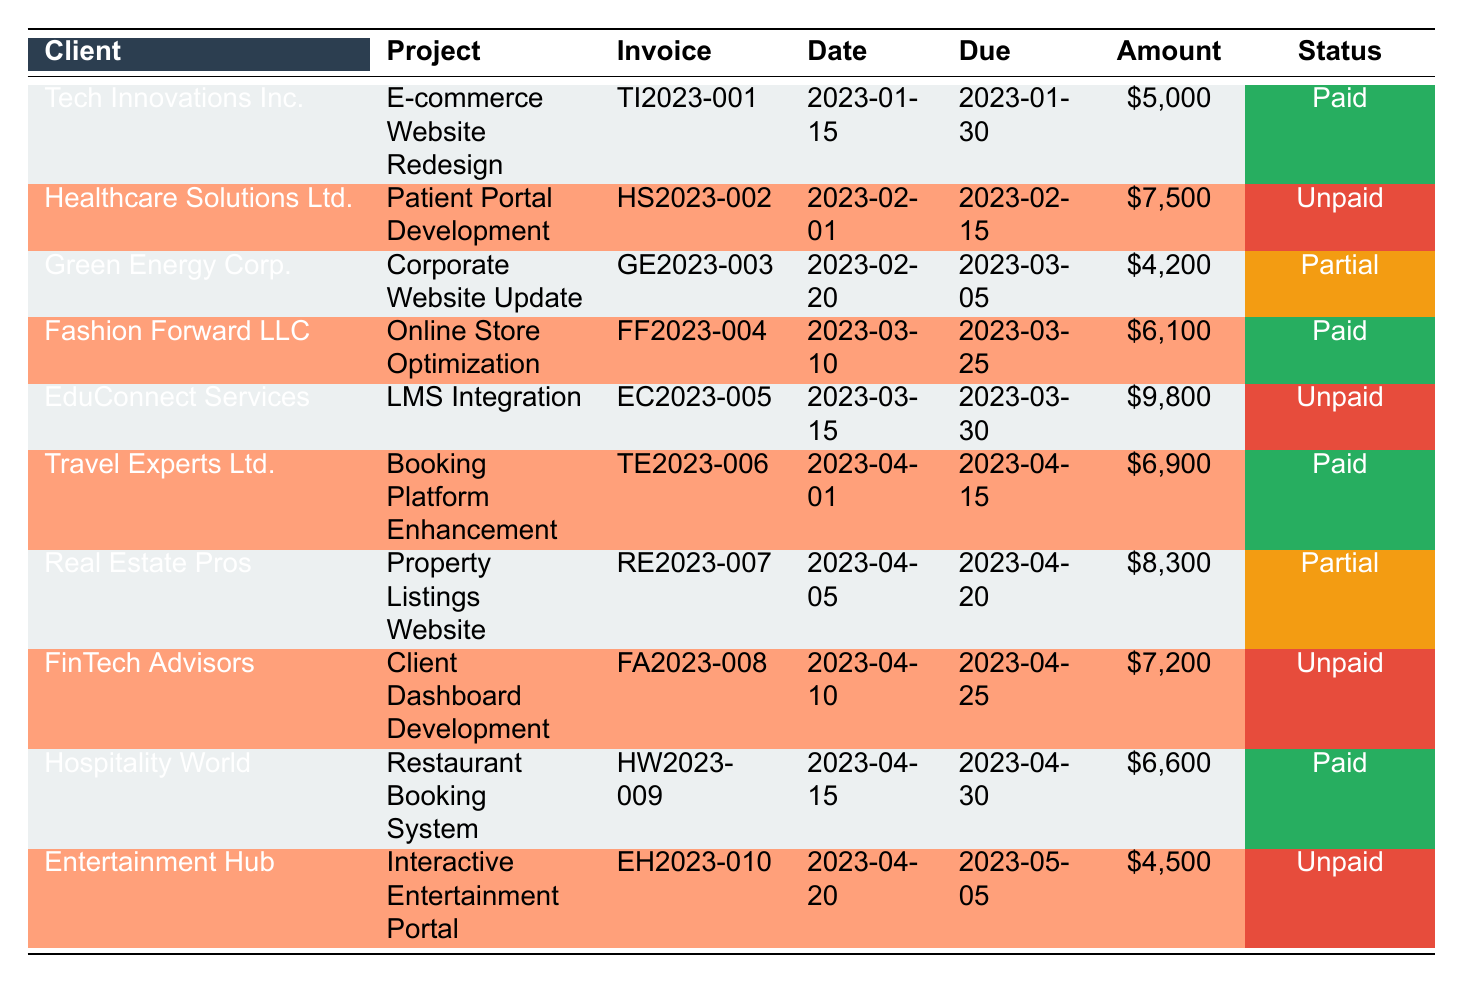What is the total amount invoiced to Tech Innovations Inc.? The total amount invoiced can be found in the table under the "Amount" column for Tech Innovations Inc., which is $5,000.
Answer: 5000 How many clients have unpaid invoices? By examining the table, we note that Healthcare Solutions Ltd., EduConnect Services, FinTech Advisors, and Entertainment Hub all have "Unpaid" listed under the "Status" column, totaling 4 clients.
Answer: 4 What is the amount paid by Green Energy Corp.? The payment amount can be derived from the "partial_payment_amount" column for Green Energy Corp., which shows $2,100 paid.
Answer: 2100 Is the invoice for Fashion Forward LLC fully paid? The table indicates that the "Status" for Fashion Forward LLC is "Paid," meaning the invoice is fully paid.
Answer: Yes What is the average invoice amount for all clients? To calculate the average, we sum the amounts: 5000 + 7500 + 4200 + 6100 + 9800 + 6900 + 8300 + 7200 + 6600 + 4500 = 58500. There are 10 clients, so the average is 58500 / 10 = 5850.
Answer: 5850 Which client had the earliest invoice date? Analyzing the "invoice_date" column, Tech Innovations Inc. had the earliest invoice date of January 15, 2023.
Answer: Tech Innovations Inc How much is the total amount unpaid across all clients? To find the total amount unpaid, we add the amounts for all clients marked as "Unpaid": 7500 + 9800 + 7200 + 4500 = 29000.
Answer: 29000 Are there any clients who have both paid and unpaid invoices? Examining the table, Real Estate Pros shows "Partially Paid" and has a previous invoice marked as unpaid, indicating that they have both paid and unpaid invoices.
Answer: Yes Which project has the highest invoice amount? By reviewing the "Amount" column, EduConnect Services has the highest invoice amount of $9,800.
Answer: EduConnect Services 